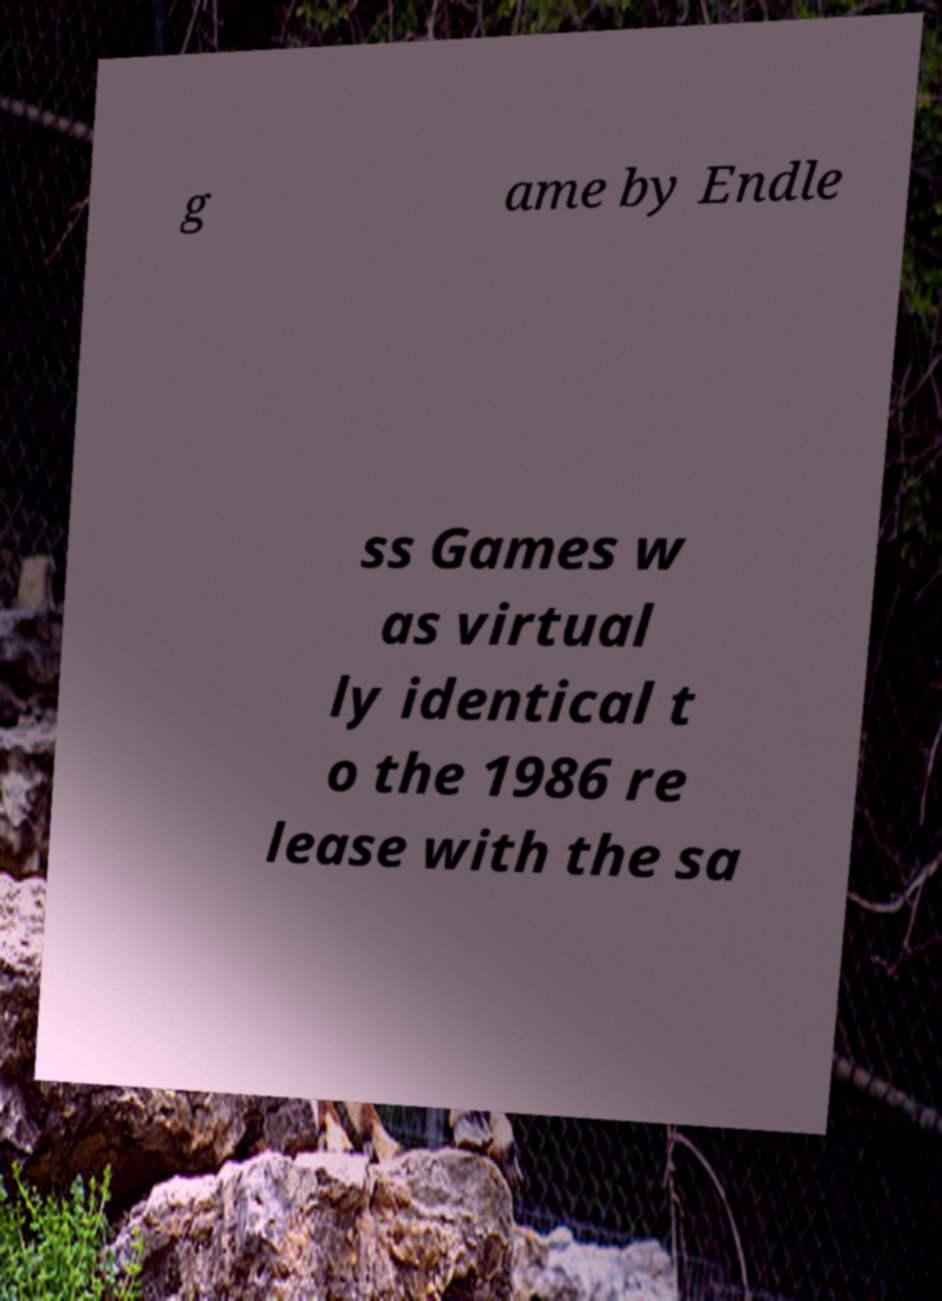Please read and relay the text visible in this image. What does it say? g ame by Endle ss Games w as virtual ly identical t o the 1986 re lease with the sa 